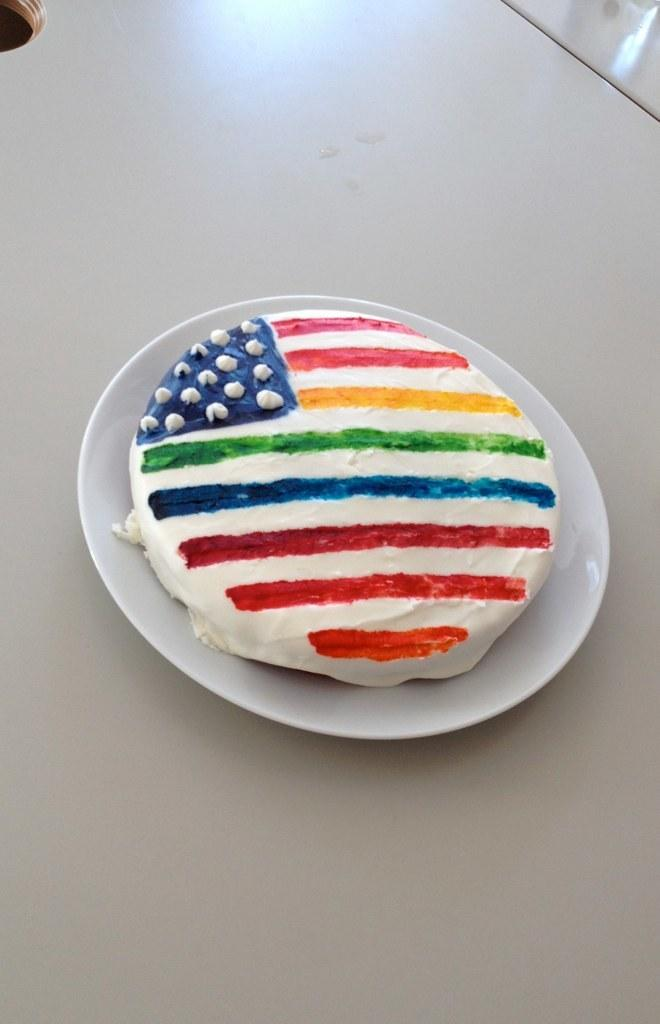What is the main subject of the image? There is a cake in the image. What is the cake placed on? The cake is on a white color plate. Where is the plate located in the image? The plate is in the middle of the image. What is the surface beneath the plate? The plate is on a white color wooden surface. Can you see any straws near the sink in the image? There is no sink or straws present in the image; it only features a cake on a plate. 